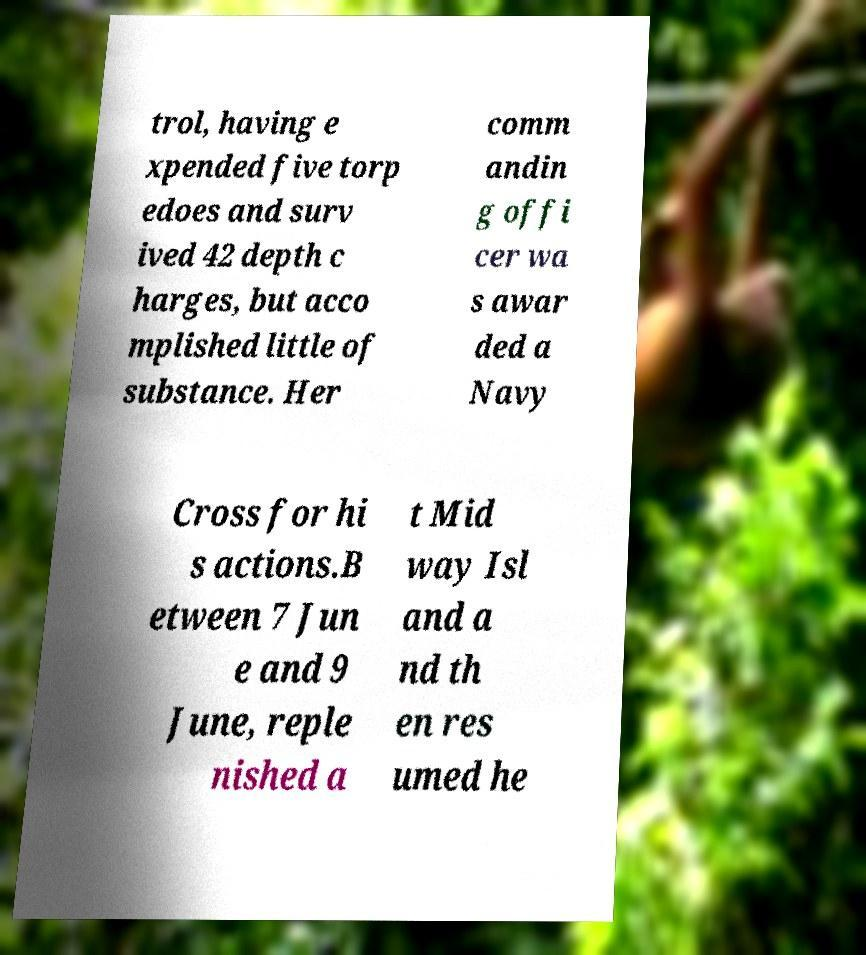For documentation purposes, I need the text within this image transcribed. Could you provide that? trol, having e xpended five torp edoes and surv ived 42 depth c harges, but acco mplished little of substance. Her comm andin g offi cer wa s awar ded a Navy Cross for hi s actions.B etween 7 Jun e and 9 June, reple nished a t Mid way Isl and a nd th en res umed he 